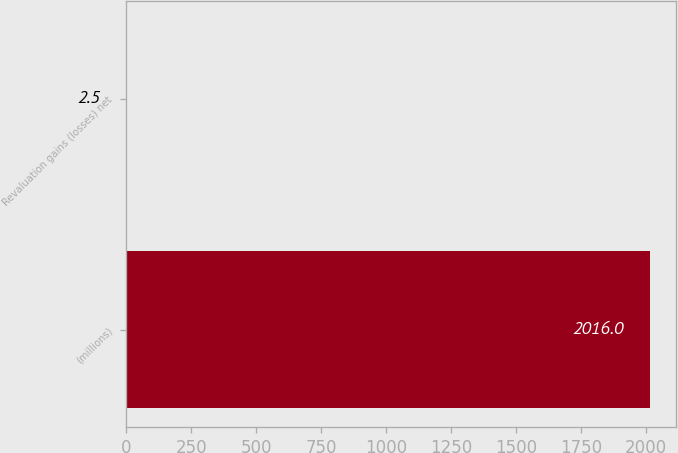Convert chart to OTSL. <chart><loc_0><loc_0><loc_500><loc_500><bar_chart><fcel>(millions)<fcel>Revaluation gains (losses) net<nl><fcel>2016<fcel>2.5<nl></chart> 